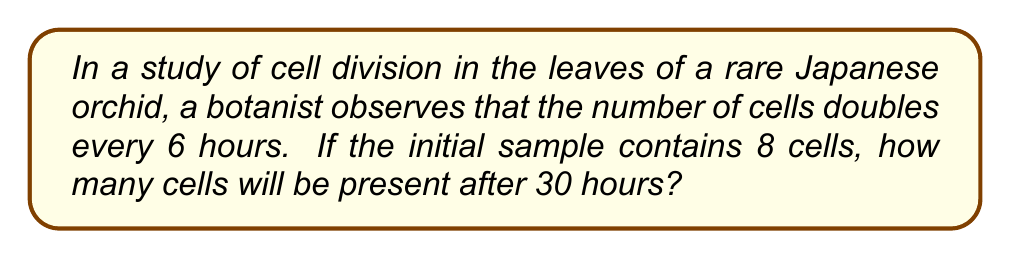Solve this math problem. Let's approach this step-by-step:

1) First, we need to identify the components of our geometric sequence:
   - Initial term, $a_1 = 8$ (initial number of cells)
   - Common ratio, $r = 2$ (the number of cells doubles each period)
   - We need to find the number of periods that occur in 30 hours

2) Calculate the number of periods:
   - Each period is 6 hours
   - Number of periods = 30 hours ÷ 6 hours = 5 periods

3) In a geometric sequence, the nth term is given by the formula:
   $a_n = a_1 \cdot r^{n-1}$

   Where:
   $a_n$ is the nth term (the number of cells after 30 hours)
   $a_1$ is the first term (8 cells)
   $r$ is the common ratio (2)
   $n$ is the number of terms (5 + 1 = 6, because we start with the initial state)

4) Plugging these values into our formula:
   $a_6 = 8 \cdot 2^{6-1} = 8 \cdot 2^5$

5) Calculate:
   $a_6 = 8 \cdot 32 = 256$

Therefore, after 30 hours, there will be 256 cells.
Answer: 256 cells 